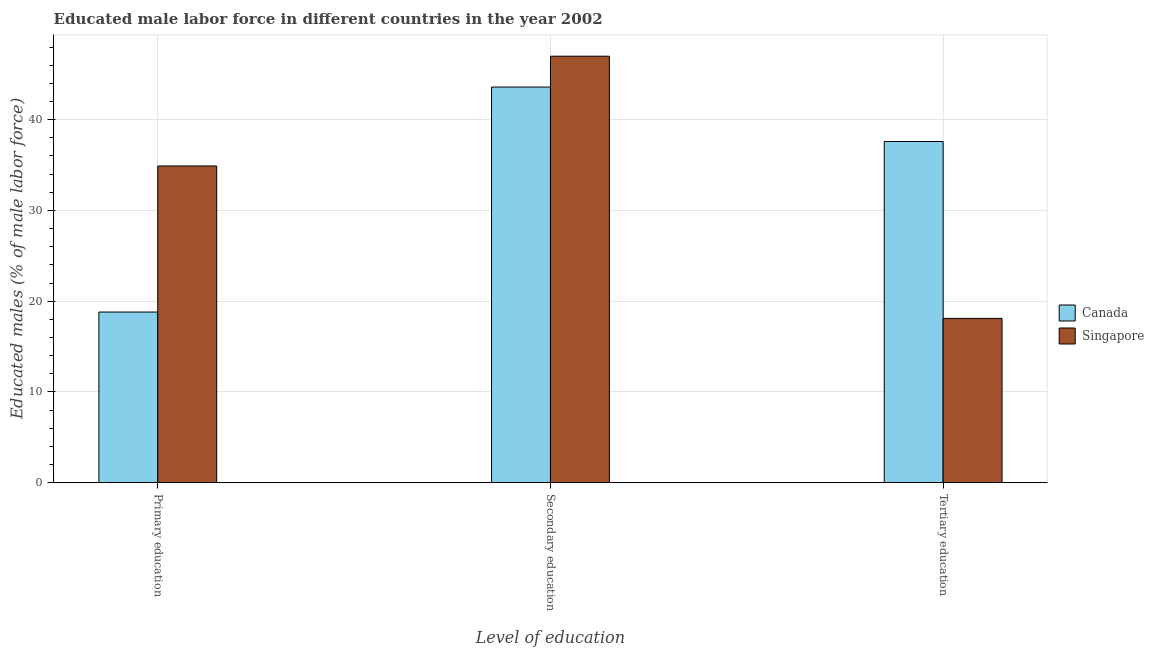How many different coloured bars are there?
Give a very brief answer. 2. Are the number of bars per tick equal to the number of legend labels?
Ensure brevity in your answer.  Yes. Are the number of bars on each tick of the X-axis equal?
Make the answer very short. Yes. How many bars are there on the 2nd tick from the left?
Keep it short and to the point. 2. How many bars are there on the 3rd tick from the right?
Your response must be concise. 2. What is the percentage of male labor force who received primary education in Singapore?
Make the answer very short. 34.9. Across all countries, what is the maximum percentage of male labor force who received tertiary education?
Provide a succinct answer. 37.6. Across all countries, what is the minimum percentage of male labor force who received tertiary education?
Give a very brief answer. 18.1. In which country was the percentage of male labor force who received primary education maximum?
Keep it short and to the point. Singapore. In which country was the percentage of male labor force who received primary education minimum?
Your response must be concise. Canada. What is the total percentage of male labor force who received tertiary education in the graph?
Your response must be concise. 55.7. What is the difference between the percentage of male labor force who received tertiary education in Canada and that in Singapore?
Provide a succinct answer. 19.5. What is the difference between the percentage of male labor force who received secondary education in Singapore and the percentage of male labor force who received tertiary education in Canada?
Your answer should be compact. 9.4. What is the average percentage of male labor force who received tertiary education per country?
Provide a short and direct response. 27.85. What is the difference between the percentage of male labor force who received secondary education and percentage of male labor force who received primary education in Singapore?
Offer a very short reply. 12.1. In how many countries, is the percentage of male labor force who received secondary education greater than 8 %?
Provide a short and direct response. 2. What is the ratio of the percentage of male labor force who received secondary education in Canada to that in Singapore?
Give a very brief answer. 0.93. Is the percentage of male labor force who received tertiary education in Singapore less than that in Canada?
Make the answer very short. Yes. Is the difference between the percentage of male labor force who received secondary education in Canada and Singapore greater than the difference between the percentage of male labor force who received primary education in Canada and Singapore?
Ensure brevity in your answer.  Yes. What is the difference between the highest and the second highest percentage of male labor force who received secondary education?
Offer a terse response. 3.4. What is the difference between the highest and the lowest percentage of male labor force who received primary education?
Offer a terse response. 16.1. What does the 2nd bar from the left in Primary education represents?
Your answer should be very brief. Singapore. Is it the case that in every country, the sum of the percentage of male labor force who received primary education and percentage of male labor force who received secondary education is greater than the percentage of male labor force who received tertiary education?
Your response must be concise. Yes. How many bars are there?
Offer a very short reply. 6. Are all the bars in the graph horizontal?
Make the answer very short. No. How many countries are there in the graph?
Offer a terse response. 2. What is the difference between two consecutive major ticks on the Y-axis?
Your answer should be very brief. 10. How are the legend labels stacked?
Provide a succinct answer. Vertical. What is the title of the graph?
Your answer should be compact. Educated male labor force in different countries in the year 2002. Does "Australia" appear as one of the legend labels in the graph?
Ensure brevity in your answer.  No. What is the label or title of the X-axis?
Make the answer very short. Level of education. What is the label or title of the Y-axis?
Your answer should be very brief. Educated males (% of male labor force). What is the Educated males (% of male labor force) in Canada in Primary education?
Your answer should be compact. 18.8. What is the Educated males (% of male labor force) of Singapore in Primary education?
Your answer should be very brief. 34.9. What is the Educated males (% of male labor force) of Canada in Secondary education?
Your answer should be compact. 43.6. What is the Educated males (% of male labor force) of Canada in Tertiary education?
Offer a very short reply. 37.6. What is the Educated males (% of male labor force) in Singapore in Tertiary education?
Your answer should be very brief. 18.1. Across all Level of education, what is the maximum Educated males (% of male labor force) of Canada?
Your response must be concise. 43.6. Across all Level of education, what is the maximum Educated males (% of male labor force) of Singapore?
Give a very brief answer. 47. Across all Level of education, what is the minimum Educated males (% of male labor force) of Canada?
Make the answer very short. 18.8. Across all Level of education, what is the minimum Educated males (% of male labor force) of Singapore?
Provide a short and direct response. 18.1. What is the total Educated males (% of male labor force) of Canada in the graph?
Ensure brevity in your answer.  100. What is the total Educated males (% of male labor force) of Singapore in the graph?
Provide a succinct answer. 100. What is the difference between the Educated males (% of male labor force) of Canada in Primary education and that in Secondary education?
Offer a terse response. -24.8. What is the difference between the Educated males (% of male labor force) in Singapore in Primary education and that in Secondary education?
Offer a terse response. -12.1. What is the difference between the Educated males (% of male labor force) of Canada in Primary education and that in Tertiary education?
Keep it short and to the point. -18.8. What is the difference between the Educated males (% of male labor force) of Singapore in Primary education and that in Tertiary education?
Keep it short and to the point. 16.8. What is the difference between the Educated males (% of male labor force) in Canada in Secondary education and that in Tertiary education?
Keep it short and to the point. 6. What is the difference between the Educated males (% of male labor force) of Singapore in Secondary education and that in Tertiary education?
Your response must be concise. 28.9. What is the difference between the Educated males (% of male labor force) of Canada in Primary education and the Educated males (% of male labor force) of Singapore in Secondary education?
Your answer should be very brief. -28.2. What is the average Educated males (% of male labor force) in Canada per Level of education?
Provide a succinct answer. 33.33. What is the average Educated males (% of male labor force) of Singapore per Level of education?
Give a very brief answer. 33.33. What is the difference between the Educated males (% of male labor force) of Canada and Educated males (% of male labor force) of Singapore in Primary education?
Your answer should be compact. -16.1. What is the ratio of the Educated males (% of male labor force) of Canada in Primary education to that in Secondary education?
Keep it short and to the point. 0.43. What is the ratio of the Educated males (% of male labor force) of Singapore in Primary education to that in Secondary education?
Keep it short and to the point. 0.74. What is the ratio of the Educated males (% of male labor force) in Singapore in Primary education to that in Tertiary education?
Offer a very short reply. 1.93. What is the ratio of the Educated males (% of male labor force) in Canada in Secondary education to that in Tertiary education?
Offer a terse response. 1.16. What is the ratio of the Educated males (% of male labor force) of Singapore in Secondary education to that in Tertiary education?
Provide a short and direct response. 2.6. What is the difference between the highest and the second highest Educated males (% of male labor force) of Singapore?
Ensure brevity in your answer.  12.1. What is the difference between the highest and the lowest Educated males (% of male labor force) of Canada?
Give a very brief answer. 24.8. What is the difference between the highest and the lowest Educated males (% of male labor force) in Singapore?
Keep it short and to the point. 28.9. 